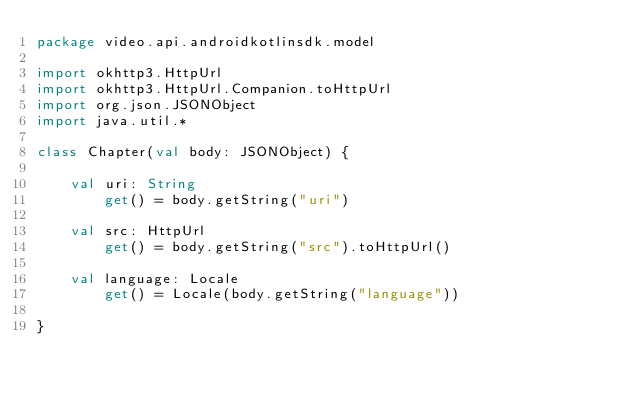<code> <loc_0><loc_0><loc_500><loc_500><_Kotlin_>package video.api.androidkotlinsdk.model

import okhttp3.HttpUrl
import okhttp3.HttpUrl.Companion.toHttpUrl
import org.json.JSONObject
import java.util.*

class Chapter(val body: JSONObject) {

    val uri: String
        get() = body.getString("uri")

    val src: HttpUrl
        get() = body.getString("src").toHttpUrl()

    val language: Locale
        get() = Locale(body.getString("language"))

}</code> 